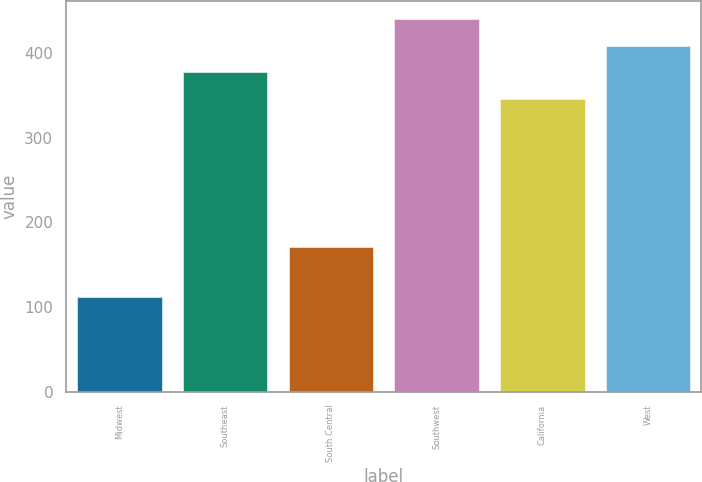Convert chart to OTSL. <chart><loc_0><loc_0><loc_500><loc_500><bar_chart><fcel>Midwest<fcel>Southeast<fcel>South Central<fcel>Southwest<fcel>California<fcel>West<nl><fcel>111.3<fcel>377.65<fcel>171.2<fcel>440.35<fcel>346.3<fcel>409<nl></chart> 